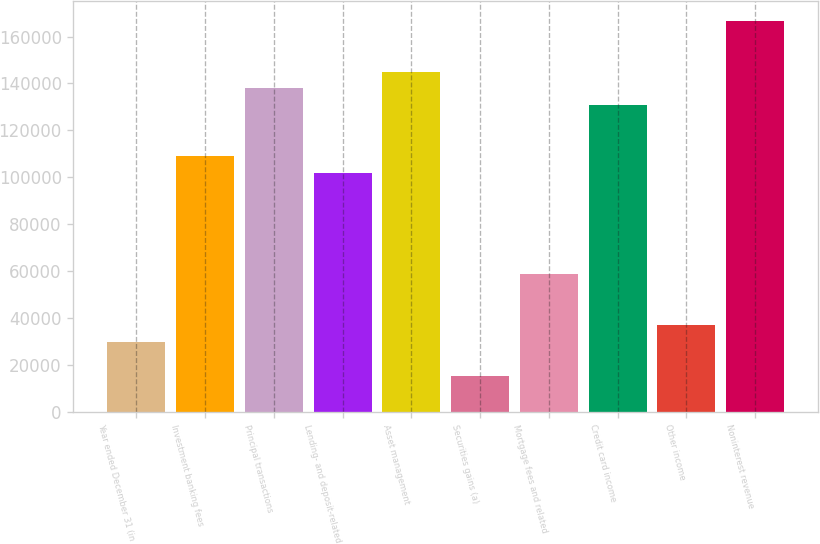Convert chart to OTSL. <chart><loc_0><loc_0><loc_500><loc_500><bar_chart><fcel>Year ended December 31 (in<fcel>Investment banking fees<fcel>Principal transactions<fcel>Lending- and deposit-related<fcel>Asset management<fcel>Securities gains (a)<fcel>Mortgage fees and related<fcel>Credit card income<fcel>Other income<fcel>Noninterest revenue<nl><fcel>29762.8<fcel>109064<fcel>137901<fcel>101855<fcel>145110<fcel>15344.4<fcel>58599.6<fcel>130692<fcel>36972<fcel>166738<nl></chart> 